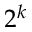Convert formula to latex. <formula><loc_0><loc_0><loc_500><loc_500>2 ^ { k }</formula> 